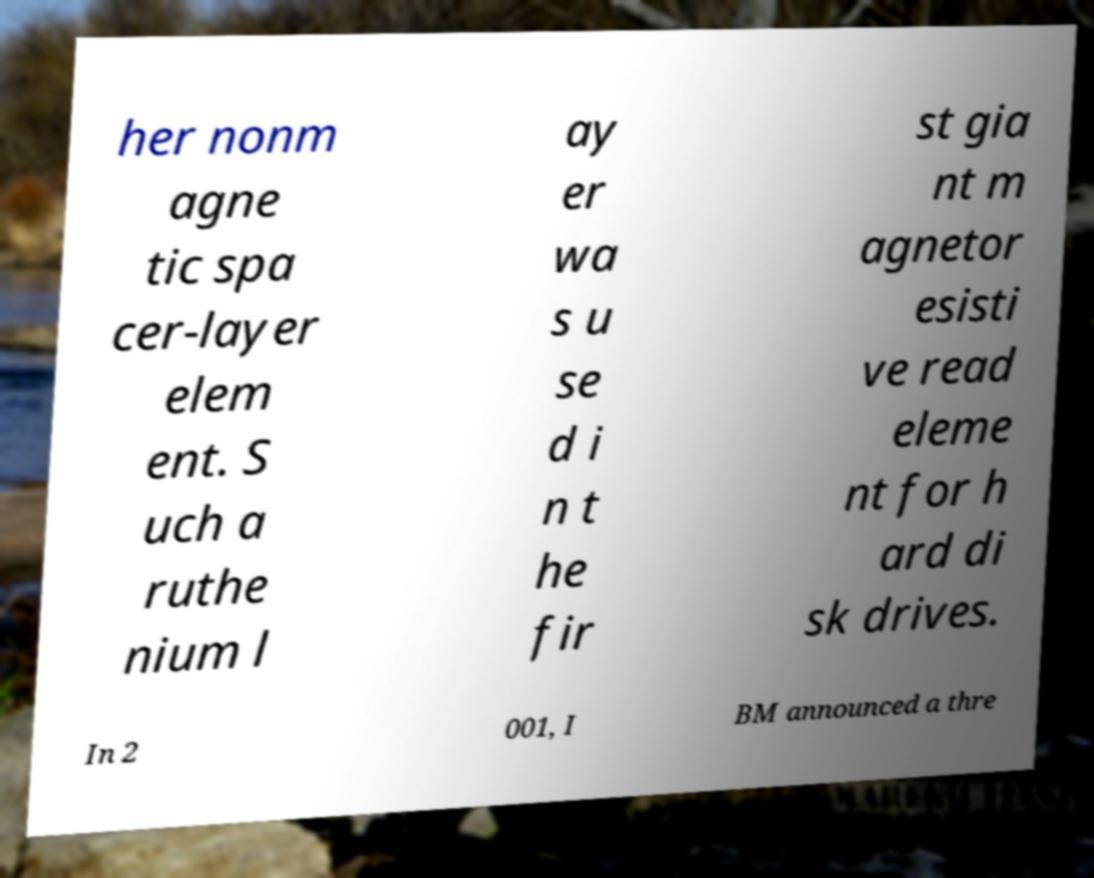Can you accurately transcribe the text from the provided image for me? her nonm agne tic spa cer-layer elem ent. S uch a ruthe nium l ay er wa s u se d i n t he fir st gia nt m agnetor esisti ve read eleme nt for h ard di sk drives. In 2 001, I BM announced a thre 